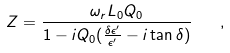<formula> <loc_0><loc_0><loc_500><loc_500>Z = \frac { \omega _ { r } L _ { 0 } Q _ { 0 } } { 1 - i Q _ { 0 } ( \frac { \delta \epsilon ^ { \prime } } { \epsilon ^ { \prime } } - i \tan \delta ) } \quad ,</formula> 